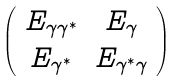<formula> <loc_0><loc_0><loc_500><loc_500>\left ( \begin{array} { c c } E _ { \gamma \gamma ^ { \ast } } & E _ { \gamma } \\ E _ { \gamma ^ { \ast } } & E _ { \gamma ^ { \ast } \gamma } \end{array} \right )</formula> 